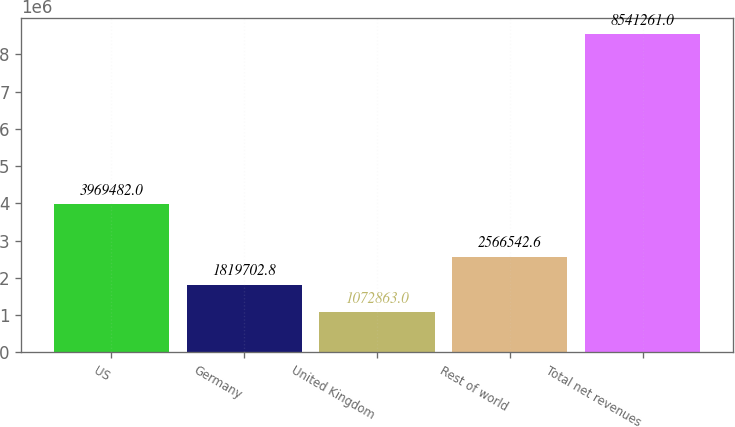Convert chart. <chart><loc_0><loc_0><loc_500><loc_500><bar_chart><fcel>US<fcel>Germany<fcel>United Kingdom<fcel>Rest of world<fcel>Total net revenues<nl><fcel>3.96948e+06<fcel>1.8197e+06<fcel>1.07286e+06<fcel>2.56654e+06<fcel>8.54126e+06<nl></chart> 